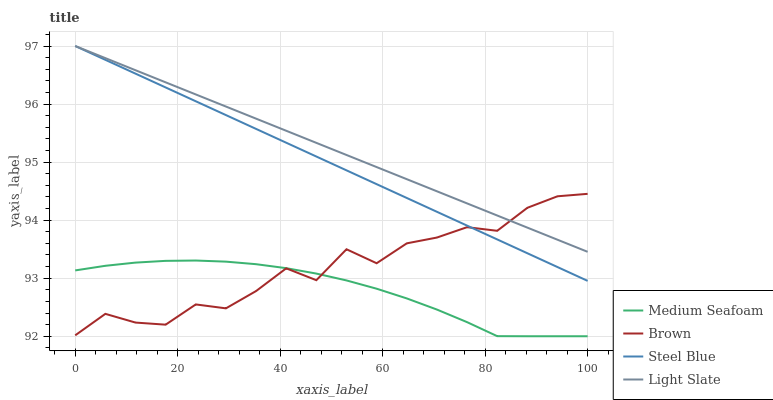Does Brown have the minimum area under the curve?
Answer yes or no. No. Does Brown have the maximum area under the curve?
Answer yes or no. No. Is Medium Seafoam the smoothest?
Answer yes or no. No. Is Medium Seafoam the roughest?
Answer yes or no. No. Does Brown have the lowest value?
Answer yes or no. No. Does Brown have the highest value?
Answer yes or no. No. Is Medium Seafoam less than Light Slate?
Answer yes or no. Yes. Is Steel Blue greater than Medium Seafoam?
Answer yes or no. Yes. Does Medium Seafoam intersect Light Slate?
Answer yes or no. No. 